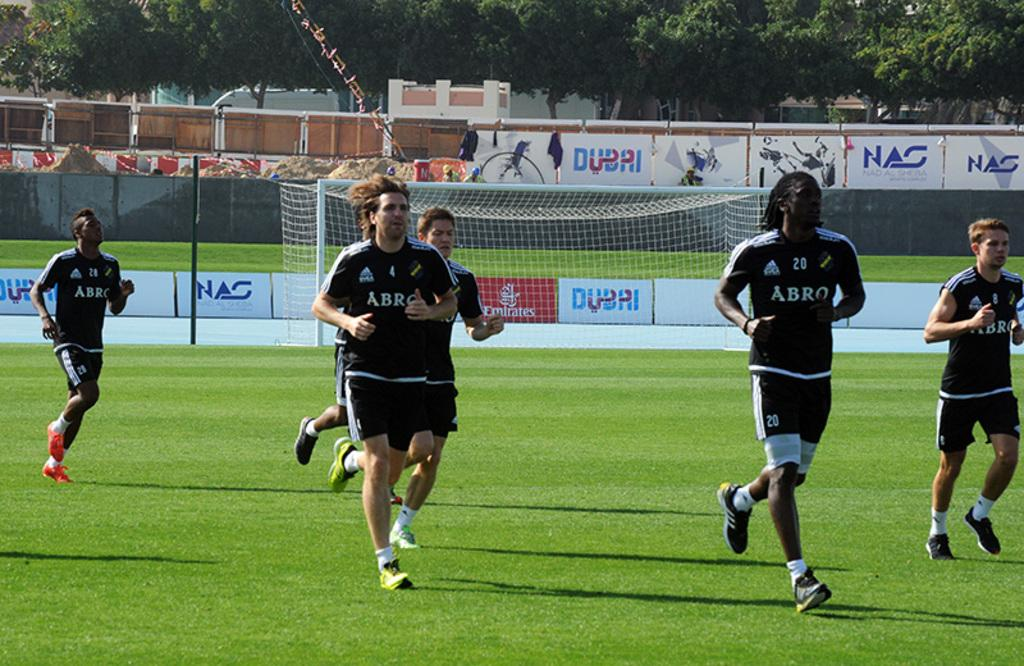<image>
Write a terse but informative summary of the picture. A group of footballers wearing black and sponsored by ABRO train on the pitch in front of advertising for Dubai and NAC 